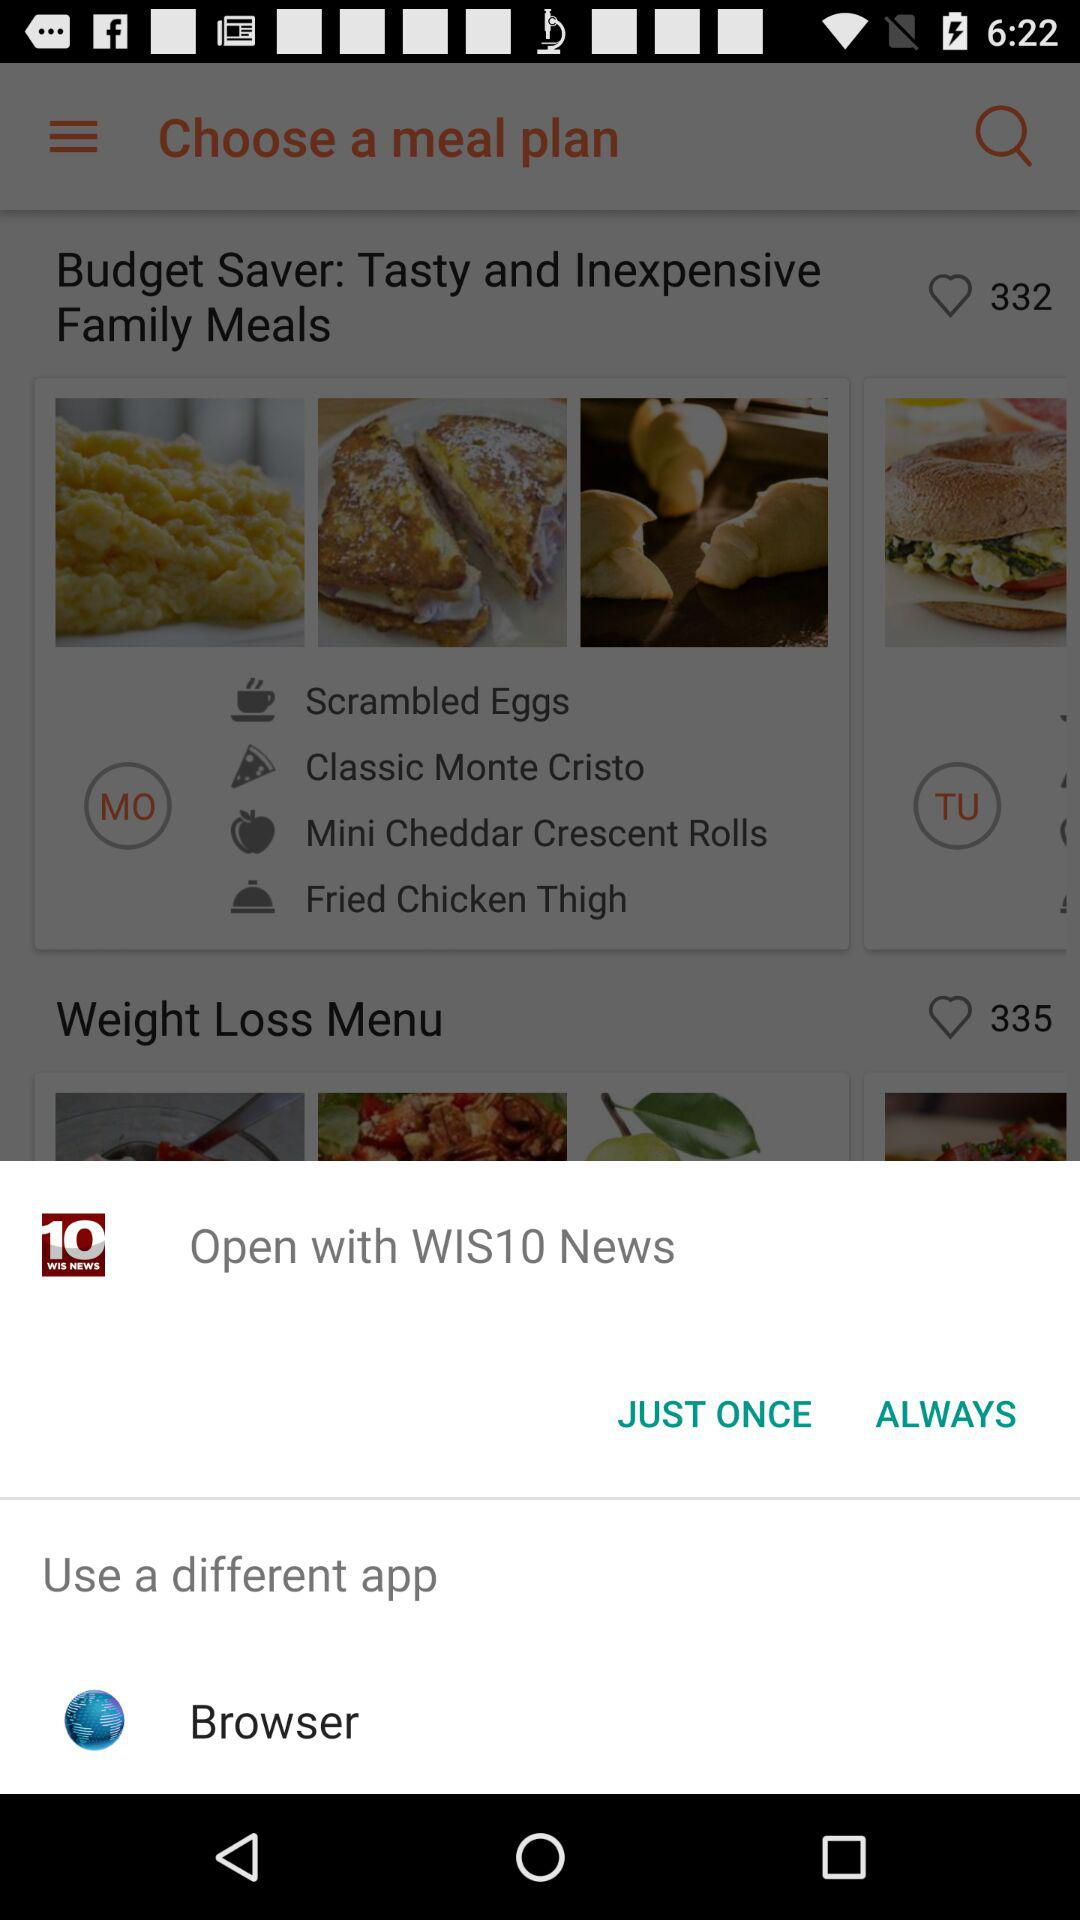What dishes are added to "Budget Saver"? The dishes added to "Budget Saver" are "Scrambled Eggs", "Classic Monte Cristo", "Mini Cheddar Crescent Rolls" and "Fried Chicken Thigh". 